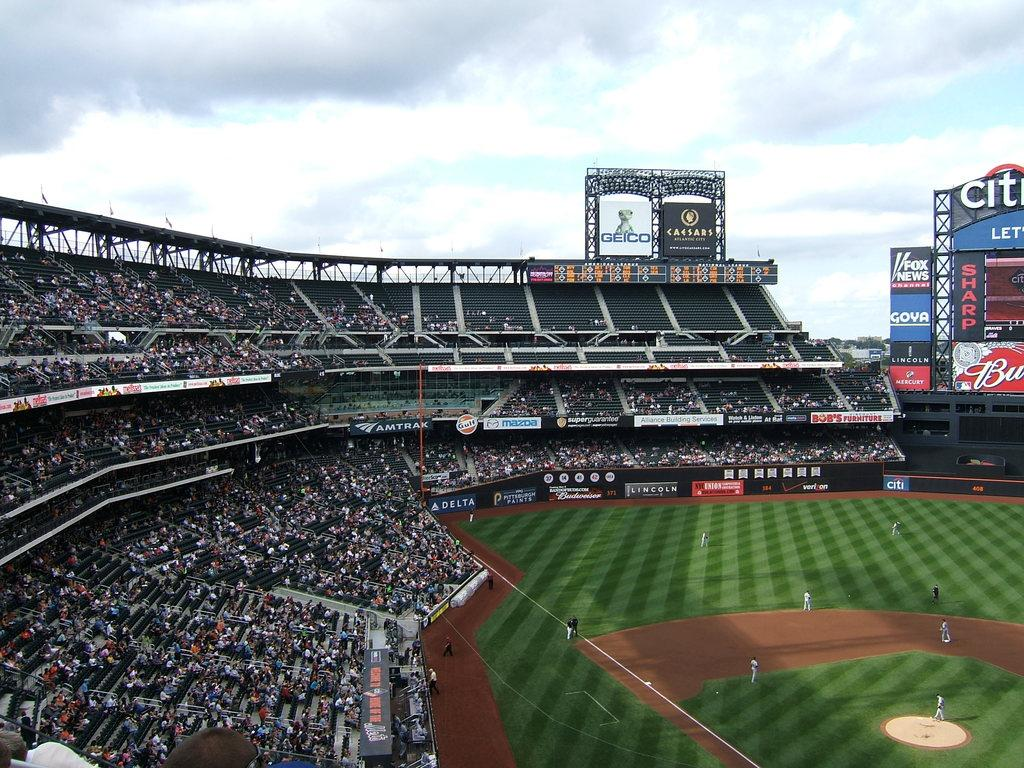Provide a one-sentence caption for the provided image. People are gathered in the stands watching baseball game at Citi Field. 